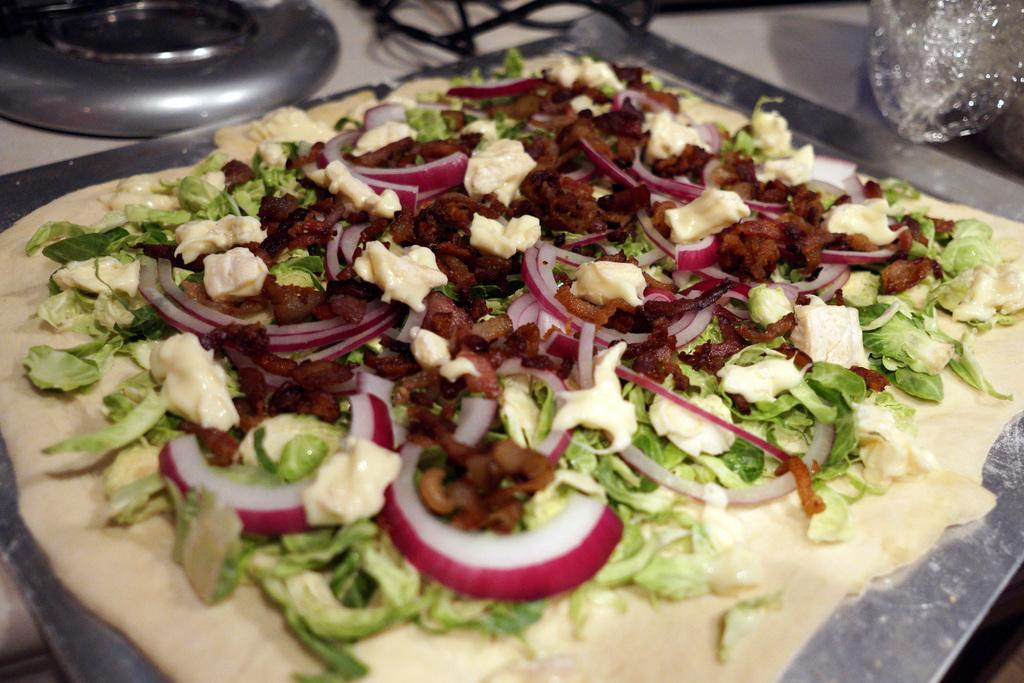What is on the stainless steel plate in the image? There is a food item on a stainless steel plate in the image. What can be seen on the top left side of the image? There is a gas burner on the top left side of the image. What type of curve can be seen in the lake in the image? There is no lake present in the image, so it is not possible to determine the type of curve in a lake. 